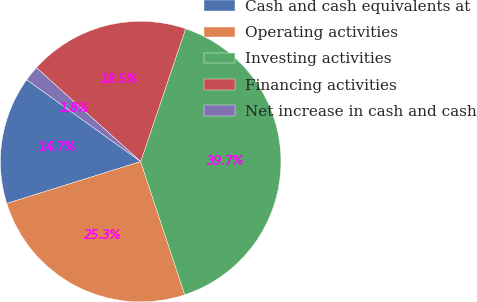<chart> <loc_0><loc_0><loc_500><loc_500><pie_chart><fcel>Cash and cash equivalents at<fcel>Operating activities<fcel>Investing activities<fcel>Financing activities<fcel>Net increase in cash and cash<nl><fcel>14.74%<fcel>25.26%<fcel>39.72%<fcel>18.53%<fcel>1.75%<nl></chart> 